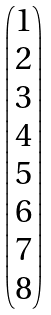Convert formula to latex. <formula><loc_0><loc_0><loc_500><loc_500>\begin{pmatrix} 1 \\ 2 \\ 3 \\ 4 \\ 5 \\ 6 \\ 7 \\ 8 \end{pmatrix}</formula> 